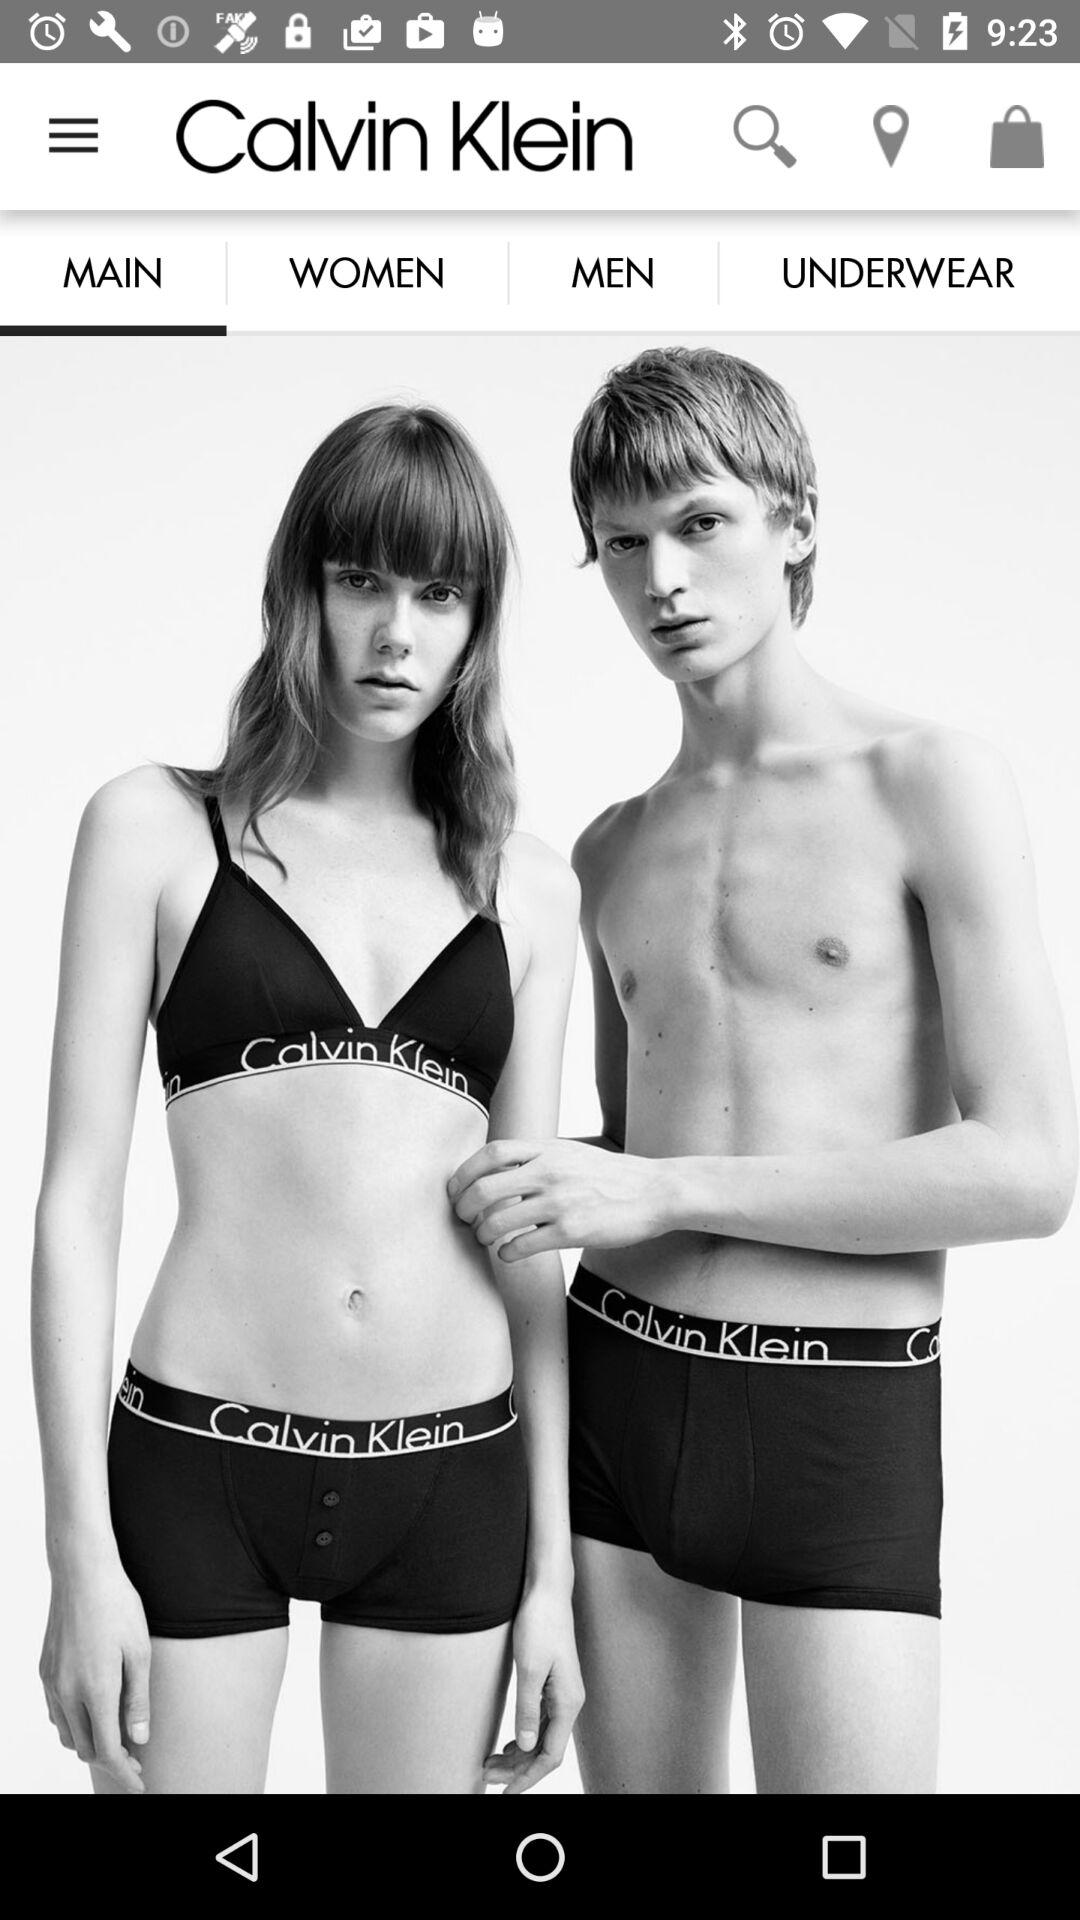Which tab is selected? The selected tab is main. 